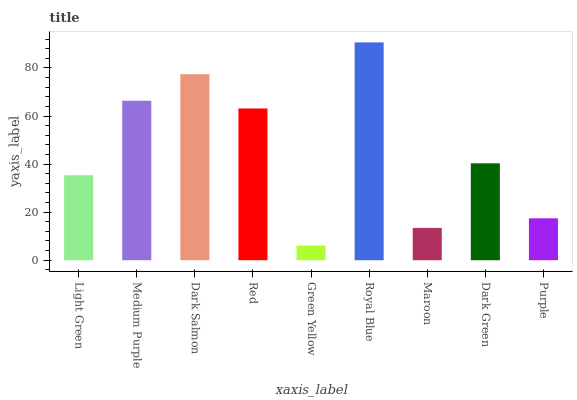Is Green Yellow the minimum?
Answer yes or no. Yes. Is Royal Blue the maximum?
Answer yes or no. Yes. Is Medium Purple the minimum?
Answer yes or no. No. Is Medium Purple the maximum?
Answer yes or no. No. Is Medium Purple greater than Light Green?
Answer yes or no. Yes. Is Light Green less than Medium Purple?
Answer yes or no. Yes. Is Light Green greater than Medium Purple?
Answer yes or no. No. Is Medium Purple less than Light Green?
Answer yes or no. No. Is Dark Green the high median?
Answer yes or no. Yes. Is Dark Green the low median?
Answer yes or no. Yes. Is Light Green the high median?
Answer yes or no. No. Is Maroon the low median?
Answer yes or no. No. 